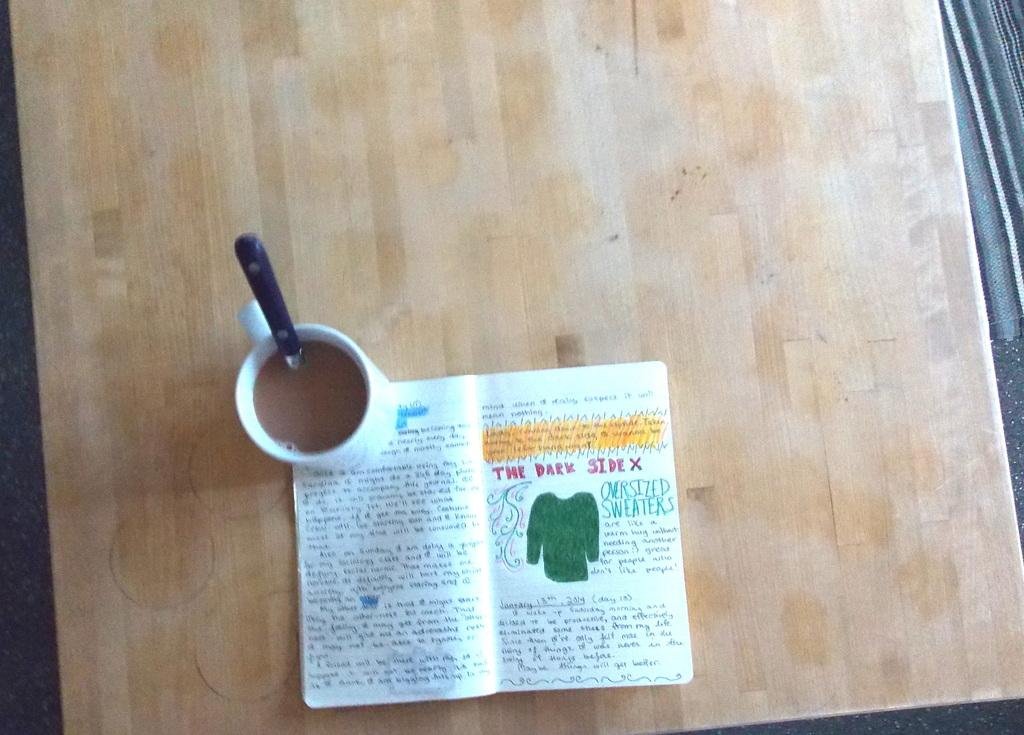<image>
Provide a brief description of the given image. A colorful book is opened to a page that says "The Dark Side" 